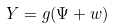<formula> <loc_0><loc_0><loc_500><loc_500>Y = g ( \Psi + w )</formula> 